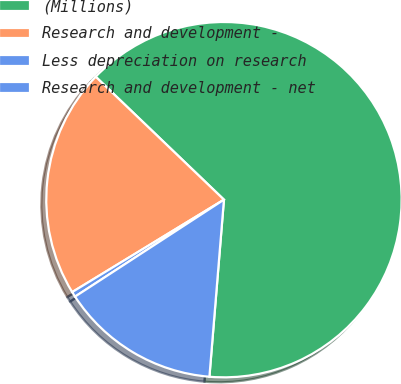Convert chart. <chart><loc_0><loc_0><loc_500><loc_500><pie_chart><fcel>(Millions)<fcel>Research and development -<fcel>Less depreciation on research<fcel>Research and development - net<nl><fcel>64.14%<fcel>20.87%<fcel>0.48%<fcel>14.51%<nl></chart> 